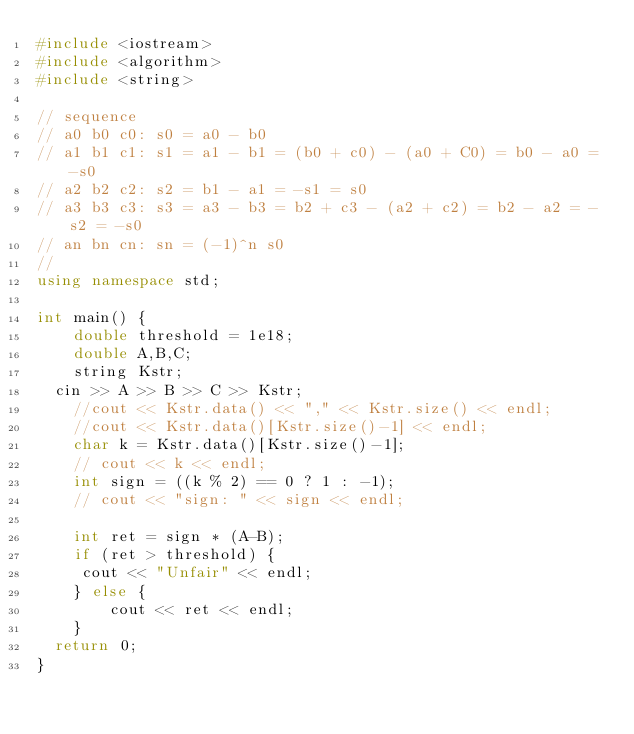<code> <loc_0><loc_0><loc_500><loc_500><_C++_>#include <iostream>
#include <algorithm>
#include <string>

// sequence
// a0 b0 c0: s0 = a0 - b0
// a1 b1 c1: s1 = a1 - b1 = (b0 + c0) - (a0 + C0) = b0 - a0 = -s0
// a2 b2 c2: s2 = b1 - a1 = -s1 = s0 
// a3 b3 c3: s3 = a3 - b3 = b2 + c3 - (a2 + c2) = b2 - a2 = -s2 = -s0 
// an bn cn: sn = (-1)^n s0
//
using namespace std;

int main() {
	double threshold = 1e18;
	double A,B,C;
	string Kstr;
  cin >> A >> B >> C >> Kstr;
	//cout << Kstr.data() << "," << Kstr.size() << endl;
	//cout << Kstr.data()[Kstr.size()-1] << endl;
	char k = Kstr.data()[Kstr.size()-1];
	// cout << k << endl;
	int sign = ((k % 2) == 0 ? 1 : -1);
	// cout << "sign: " << sign << endl;
	
	int ret = sign * (A-B);	
	if (ret > threshold) {
	 cout << "Unfair" << endl;	
	} else {
		cout << ret << endl;
	}
  return 0;
}	

</code> 